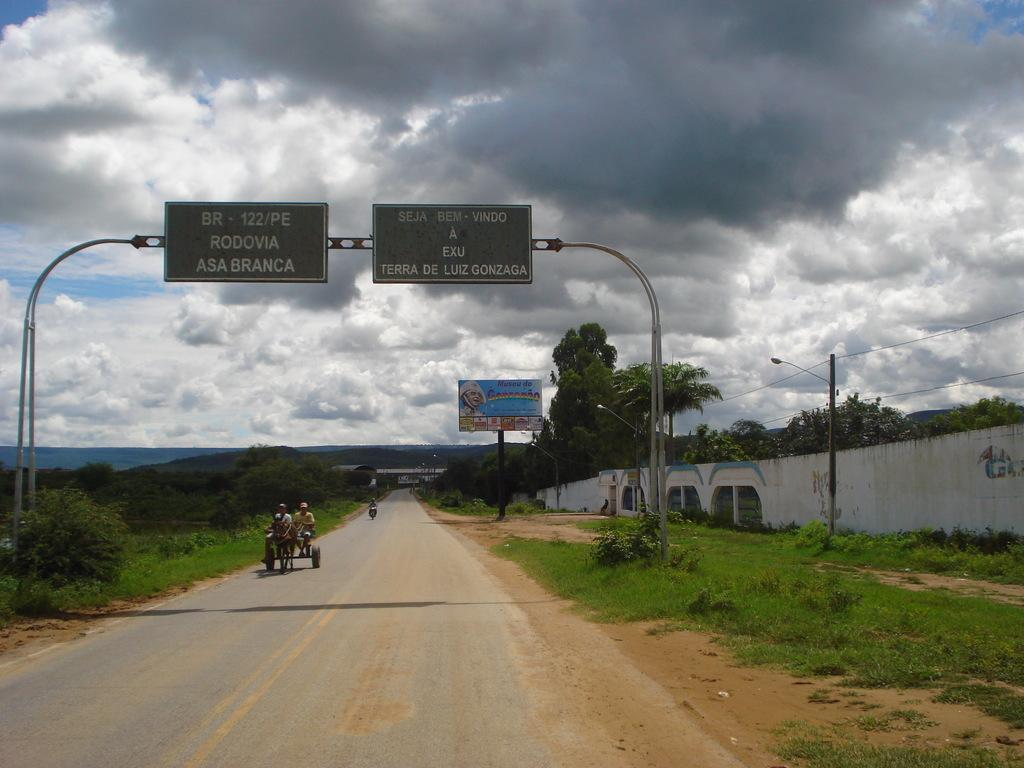<image>
Describe the image concisely. People riding under a highway sign that says "Rodovia Asa Branca". 